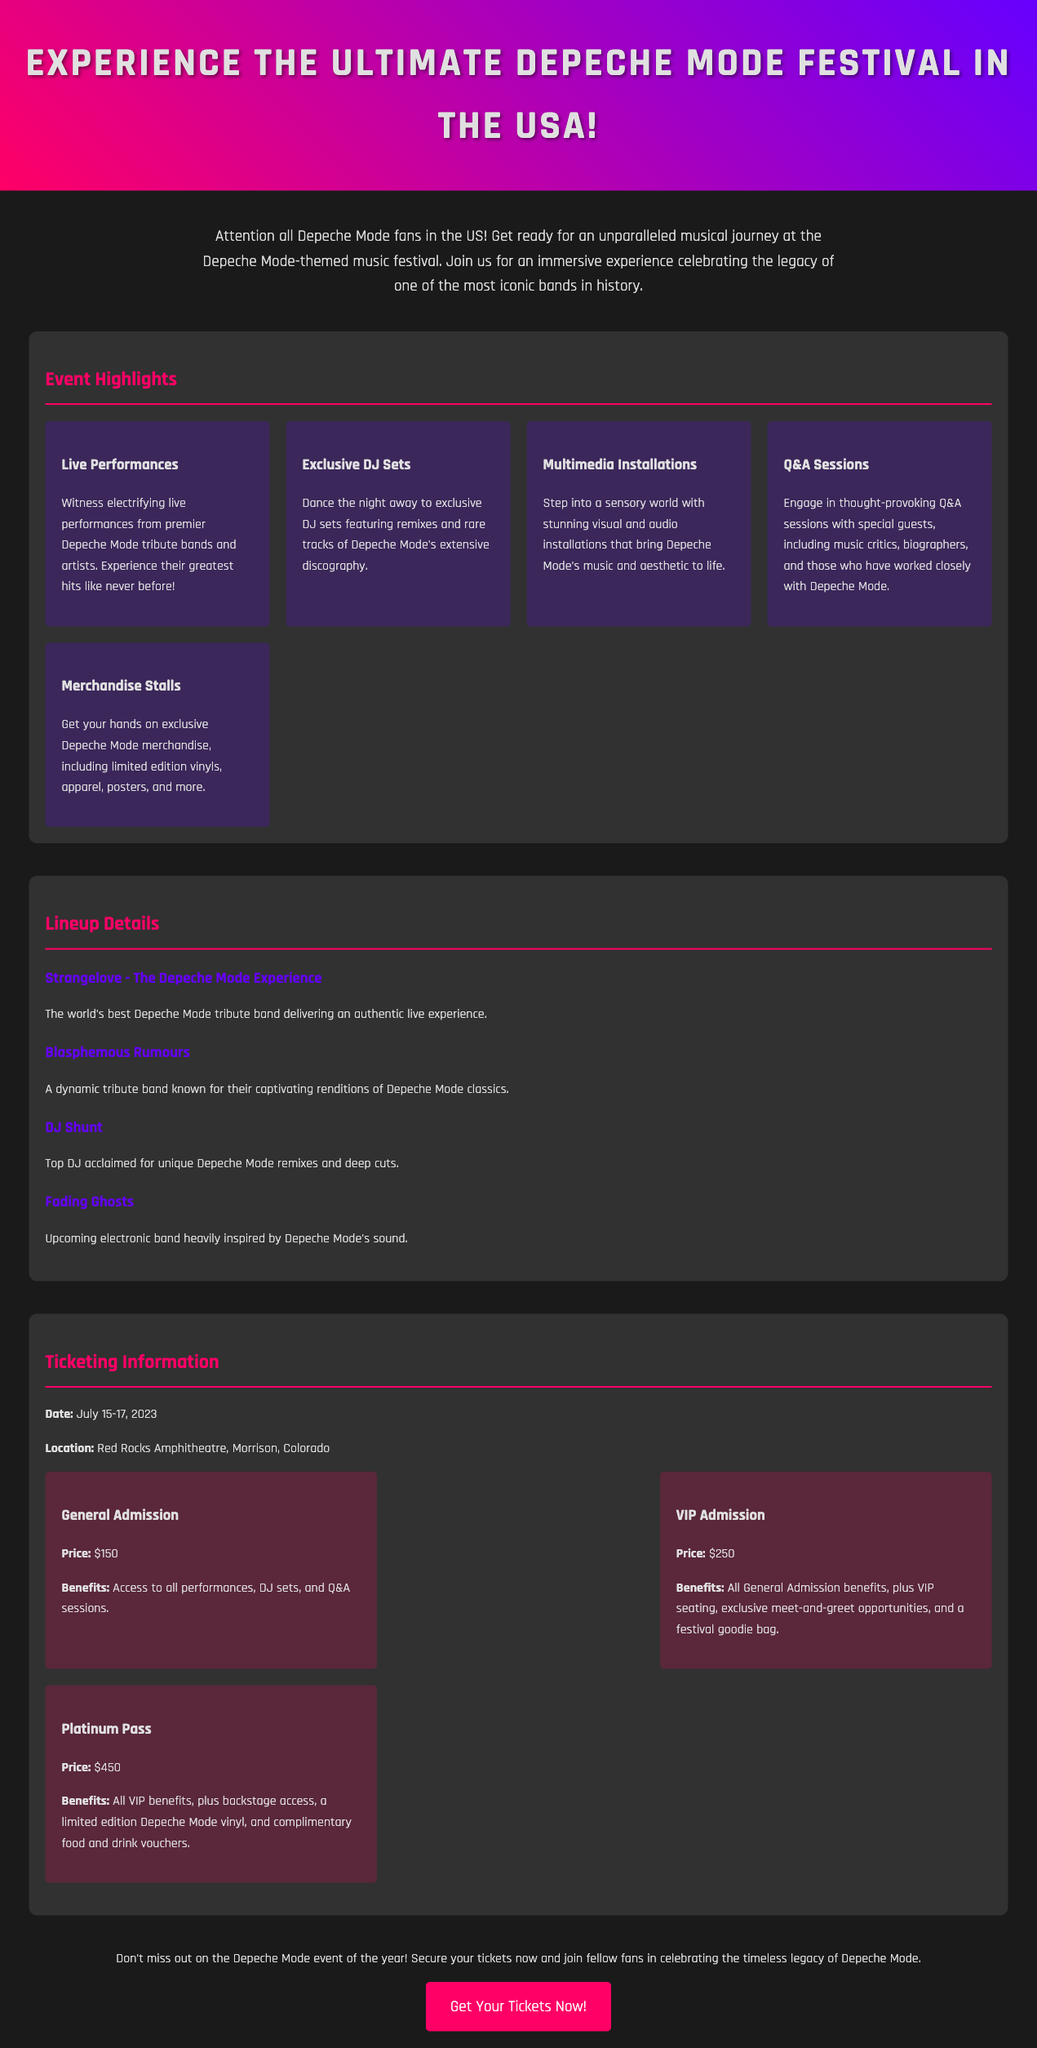What are the dates of the festival? The document specifies the festival dates as July 15-17, 2023.
Answer: July 15-17, 2023 Where is the festival located? The document states the location of the festival as Red Rocks Amphitheatre, Morrison, Colorado.
Answer: Red Rocks Amphitheatre, Morrison, Colorado What is the price of VIP Admission? The VIP Admission price is mentioned as $250 in the ticketing section.
Answer: $250 What type of performances can attendees expect? The document highlights live performances from Depeche Mode tribute bands and artists.
Answer: Live performances Who is the DJ mentioned in the lineup? DJ Shunt is specifically mentioned as a top DJ in the lineup details.
Answer: DJ Shunt What benefit does the Platinum Pass offer? The document lists backstage access as one of the benefits of the Platinum Pass.
Answer: Backstage access How many tribute bands are listed in the lineup? The lineup details mention four tribute bands.
Answer: Four What is the call to action in the document? The document encourages securing tickets now and joining fellow fans.
Answer: Get Your Tickets Now! 